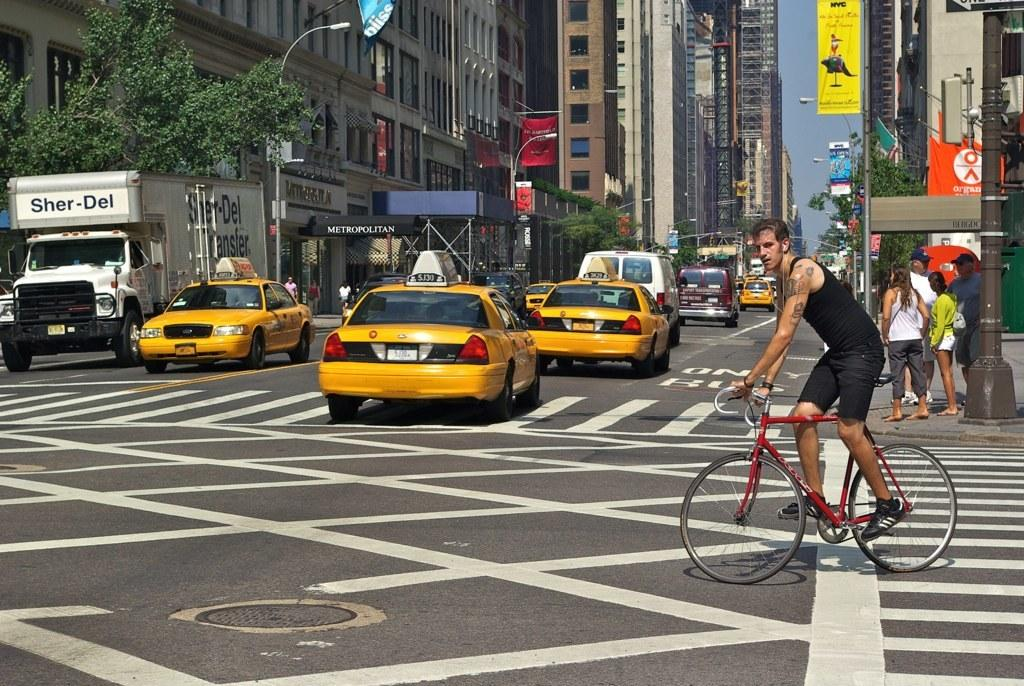<image>
Provide a brief description of the given image. A busy New York street scene contains a canopy in the background which reads Metropolitan. 